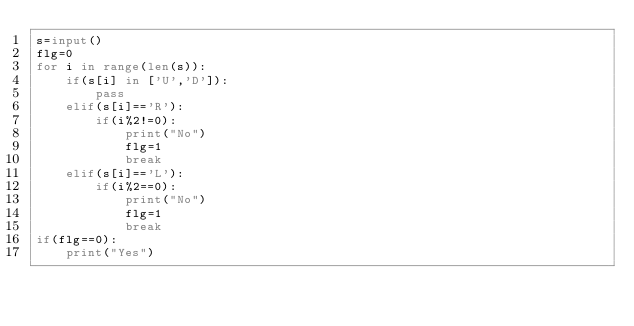<code> <loc_0><loc_0><loc_500><loc_500><_Python_>s=input()
flg=0
for i in range(len(s)):
    if(s[i] in ['U','D']):
        pass
    elif(s[i]=='R'):
        if(i%2!=0):
            print("No")
            flg=1
            break
    elif(s[i]=='L'):
        if(i%2==0):
            print("No")
            flg=1
            break
if(flg==0):
    print("Yes")



   </code> 